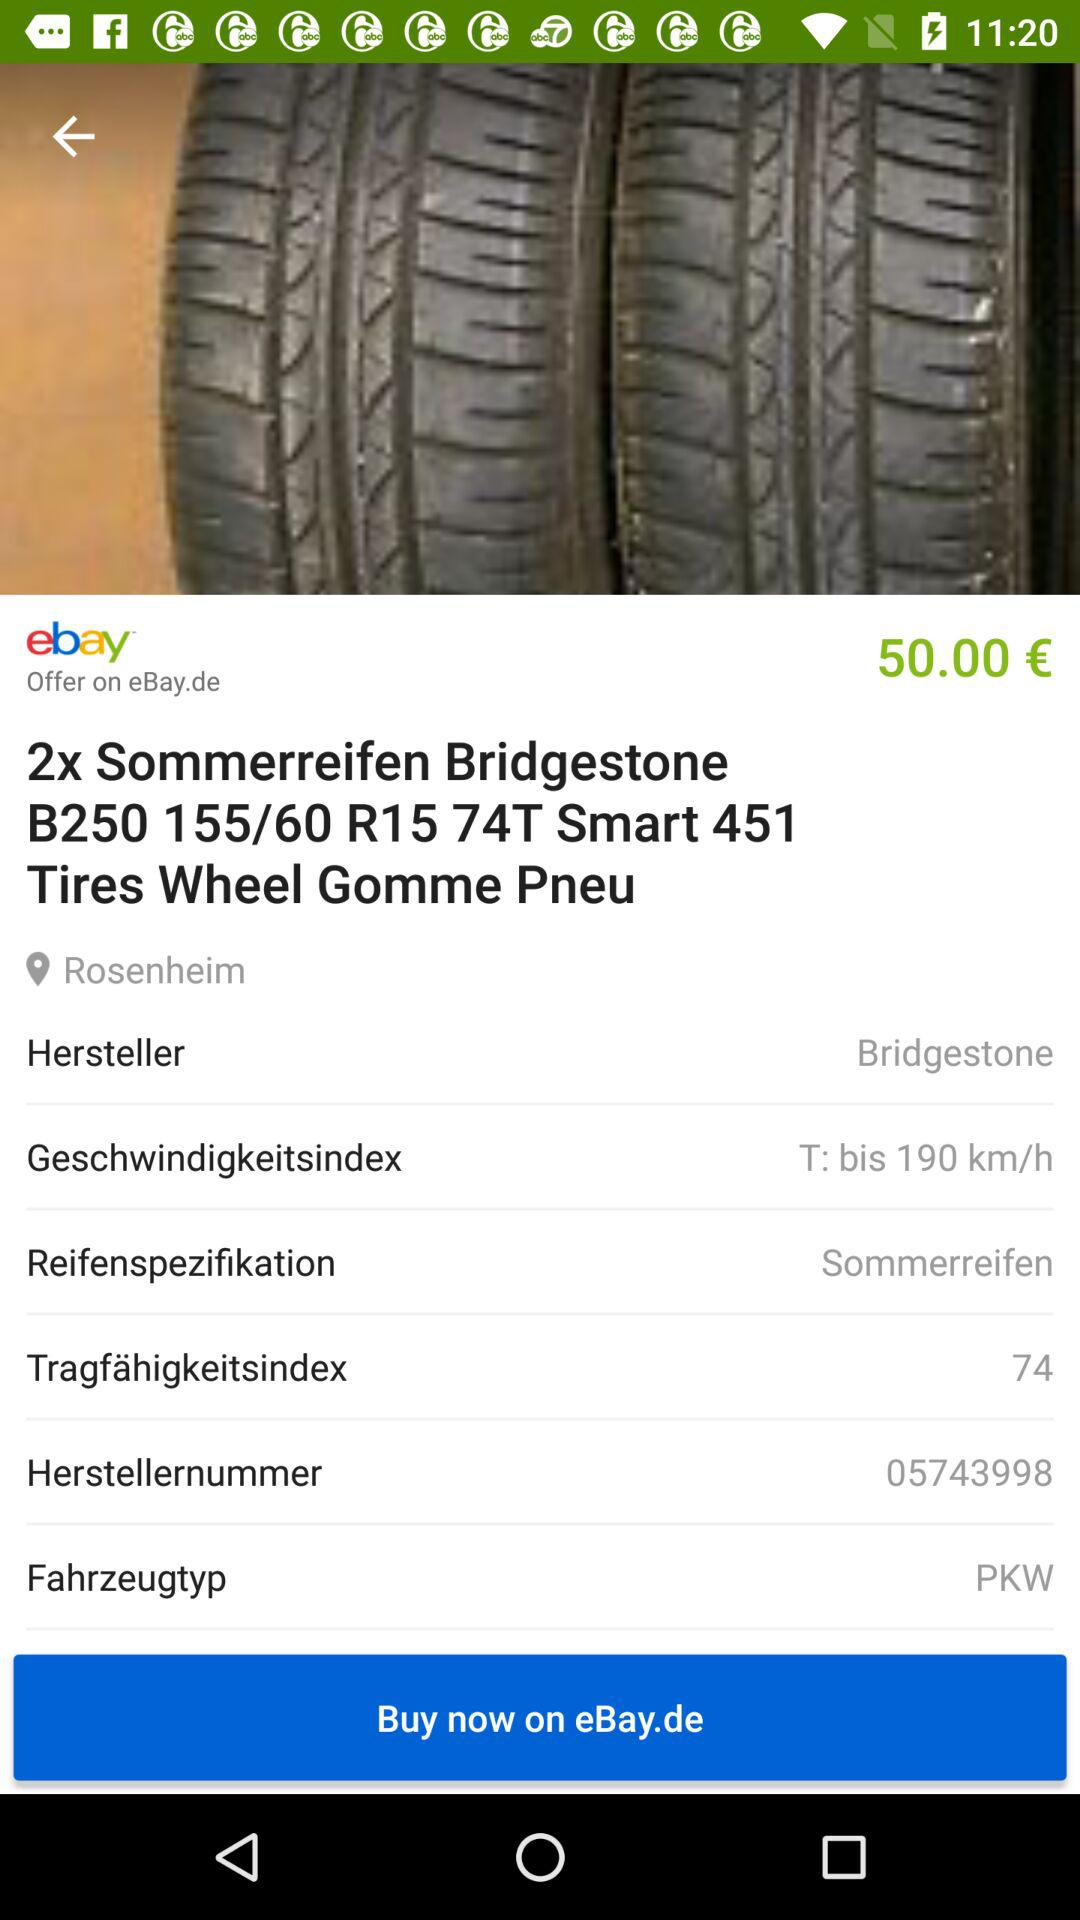What is the price of the product? The price of the product is €50.00. 